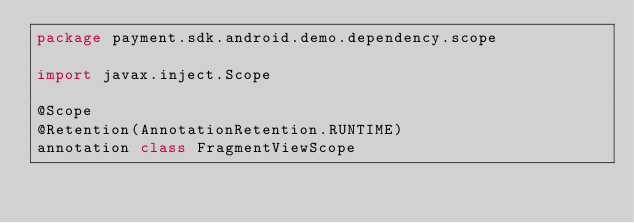Convert code to text. <code><loc_0><loc_0><loc_500><loc_500><_Kotlin_>package payment.sdk.android.demo.dependency.scope

import javax.inject.Scope

@Scope
@Retention(AnnotationRetention.RUNTIME)
annotation class FragmentViewScope
</code> 